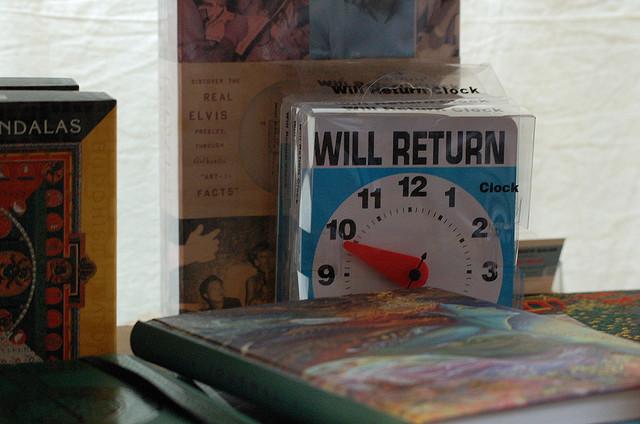Is the clock currently in use?
Quick response, please. No. What will the clock be used for?
Concise answer only. Lunch break. What does it say on top of the clock?
Answer briefly. Will return. What does the last word on the sticker?
Short answer required. Return. 